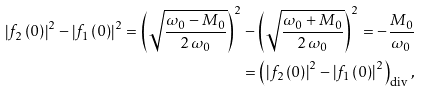<formula> <loc_0><loc_0><loc_500><loc_500>\left | f _ { 2 } \left ( 0 \right ) \right | ^ { 2 } - \left | f _ { 1 } \left ( 0 \right ) \right | ^ { 2 } = \left ( \sqrt { \frac { \omega _ { 0 } - M _ { 0 } } { 2 \, \omega _ { 0 } } } \right ) ^ { 2 } - \left ( \sqrt { \frac { \omega _ { 0 } + M _ { 0 } } { 2 \, \omega _ { 0 } } } \right ) ^ { 2 } = - \frac { M _ { 0 } } { \omega _ { 0 } } \\ = \left ( \left | f _ { 2 } \left ( 0 \right ) \right | ^ { 2 } - \left | f _ { 1 } \left ( 0 \right ) \right | ^ { 2 } \right ) _ { \text {div} } ,</formula> 